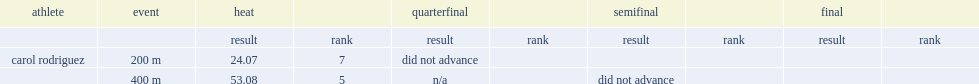How many seconds did rodriguez achieve a time of in the heat? 24.07. 